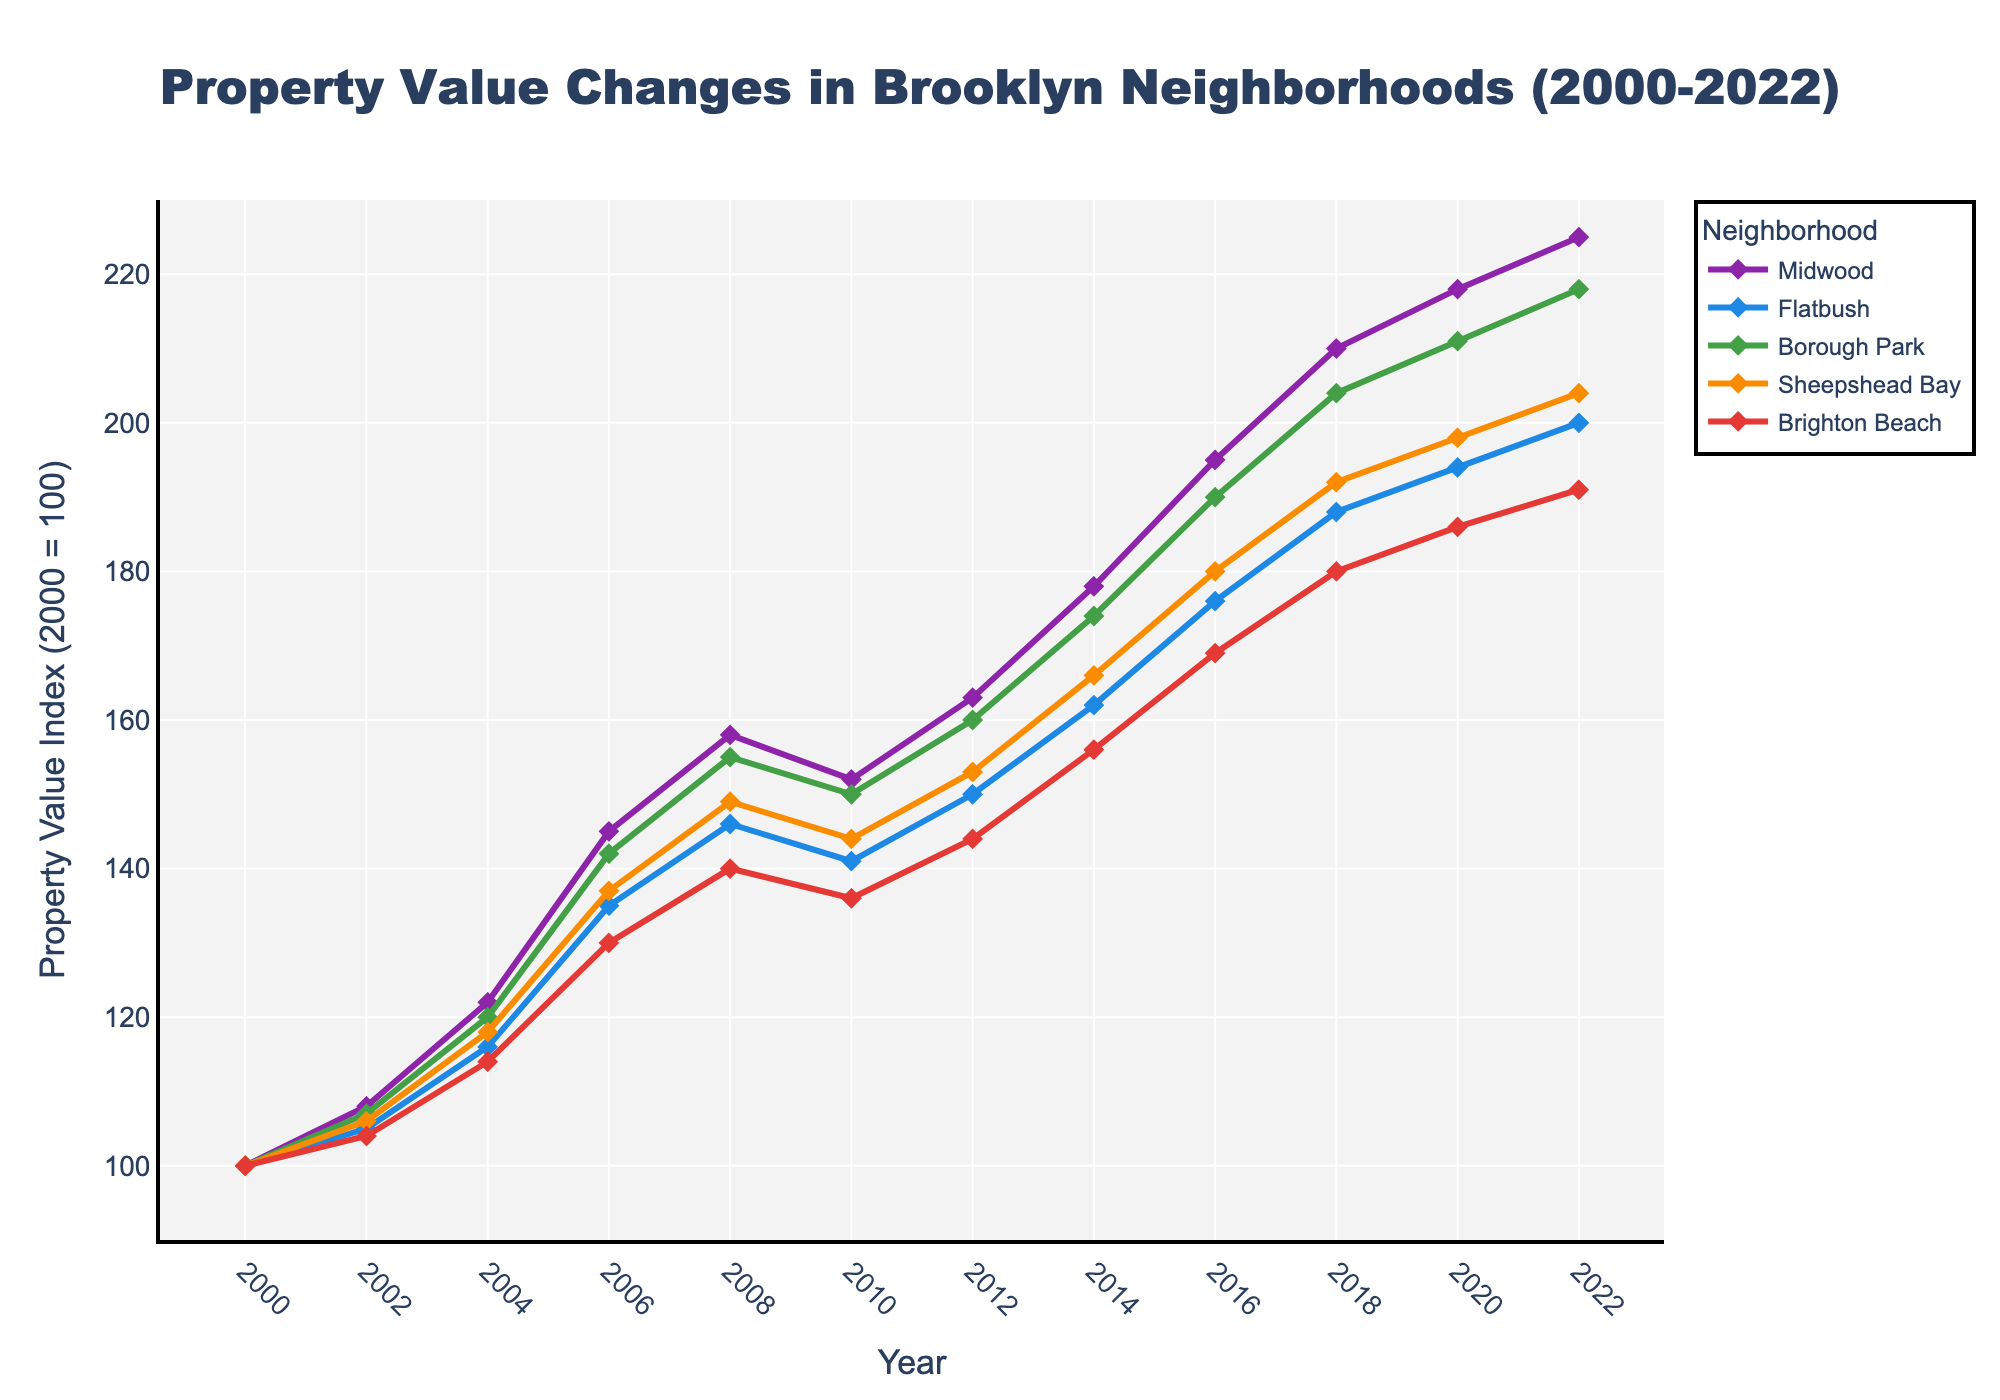What's the total property value index increase in Midwood from 2000 to 2022? The property value index for Midwood in 2000 is 100, and it increases to 225 in 2022. The increase is 225 - 100 = 125.
Answer: 125 Which neighborhood had the smallest increase in property value index from 2000 to 2022? To find the smallest increase, we subtract the 2000 values from the 2022 values for each neighborhood. The smallest increase is for Brighton Beach: 191 - 100 = 91.
Answer: Brighton Beach In which year did property values in Midwood surpass 150 for the first time? Looking at the line chart for Midwood, we see that the property value index first surpasses 150 in 2006.
Answer: 2006 Between which consecutive years did Flatbush experience the largest increase in property value index? By calculating the differences between consecutive years for Flatbush, we find the largest increase is between 2004 and 2006 with an increase from 116 to 135 (135 - 116 = 19).
Answer: 2004-2006 How do the property values in Borough Park in 2010 compare to those in Sheepshead Bay in the same year? Referring to the figure, Borough Park's property value index in 2010 is 150, while Sheepshead Bay’s is 144.
Answer: Borough Park had a higher value than Sheepshead Bay in 2010 Which neighborhood has the steadiest growth in property values from 2000 to 2022? Steadiest growth can be interpreted as having the smoothest, most consistent upward trend. Flatbush shows a relatively steady and consistent increase compared to other neighborhoods.
Answer: Flatbush What is the average property value index for Brighton Beach across all years shown? Sum all index values for Brighton Beach and divide by the number of years. (100 + 104 + 114 + 130 + 140 + 136 + 144 + 156 + 169 + 180 + 186 + 191) / 12 = 1483 / 12 = 123.58
Answer: 123.58 Considering the data points in the figure, in which year did Midwood’s property value index equal Sheepshead Bay's property value index? According to the figure, Midwood’s property value index equals Sheepshead Bay’s property value index in 2010, both being 144.
Answer: 2010 Between 2006 and 2012, which neighborhood experienced the most significant drop in property value index, and by how much? From 2006 to 2012, we calculate the property value index drop for each neighborhood. Borough Park dropped from 142 to 160, but the drop isn’t negative, so Flatbush, Sheepshead Bay, and Brighton Beach's reductions do not surpass Borough Park's consistent rise. Thus, none experienced a drop; they all rose in value.
Answer: None 